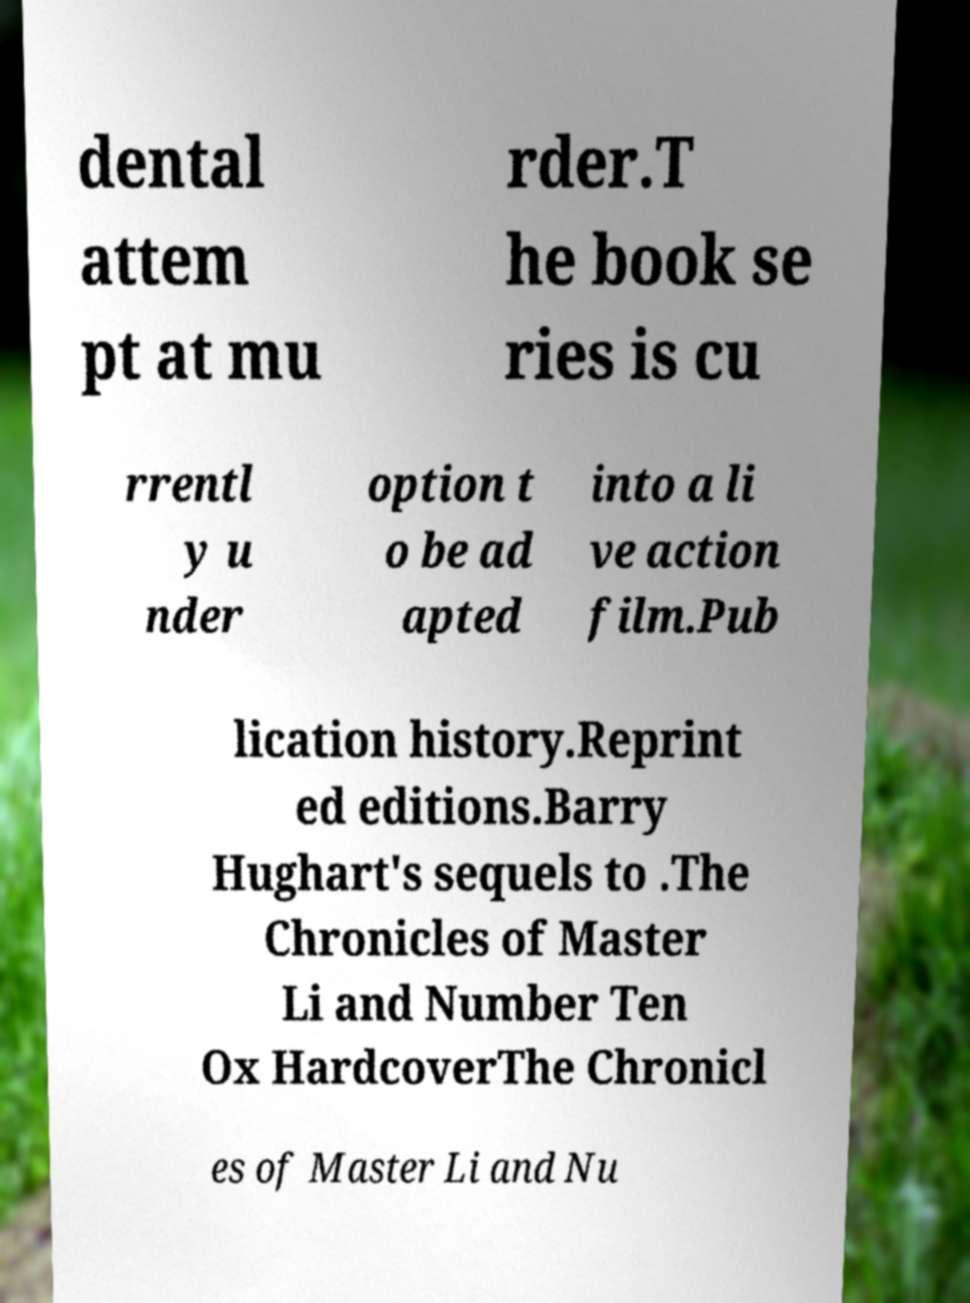Can you read and provide the text displayed in the image?This photo seems to have some interesting text. Can you extract and type it out for me? dental attem pt at mu rder.T he book se ries is cu rrentl y u nder option t o be ad apted into a li ve action film.Pub lication history.Reprint ed editions.Barry Hughart's sequels to .The Chronicles of Master Li and Number Ten Ox HardcoverThe Chronicl es of Master Li and Nu 